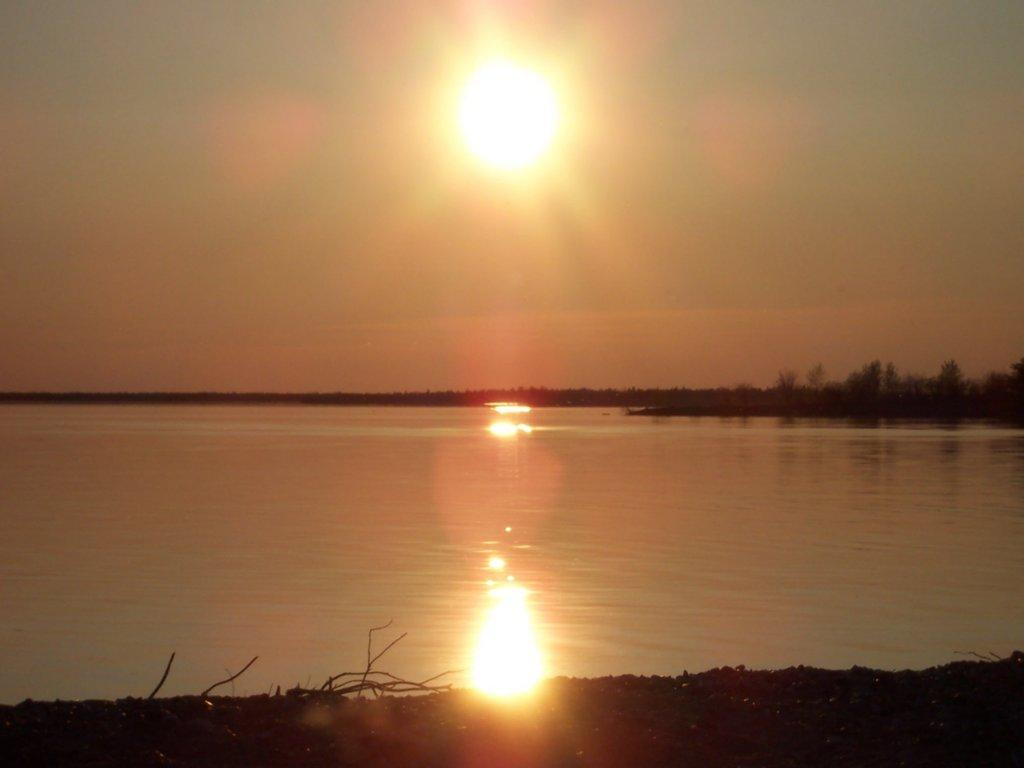What is the primary element visible in the image? There is water in the image. What type of vegetation can be seen in the image? There are trees in the image. What celestial body is visible in the sky in the image? The sun is visible in the sky in the image. What tax rate applies to the water in the image? There is no tax rate mentioned or implied in the image, as it is a visual representation of water, trees, and the sun. 